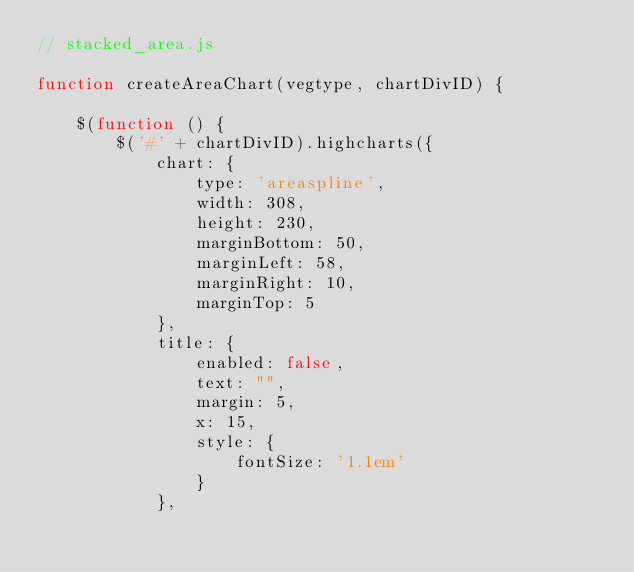<code> <loc_0><loc_0><loc_500><loc_500><_JavaScript_>// stacked_area.js

function createAreaChart(vegtype, chartDivID) {

    $(function () {
        $('#' + chartDivID).highcharts({
            chart: {
                type: 'areaspline',
                width: 308,
                height: 230,
                marginBottom: 50,
                marginLeft: 58,
                marginRight: 10,
                marginTop: 5
            },
            title: {
                enabled: false,
                text: "",
                margin: 5,
                x: 15,
                style: {
                    fontSize: '1.1em'
                }
            },</code> 